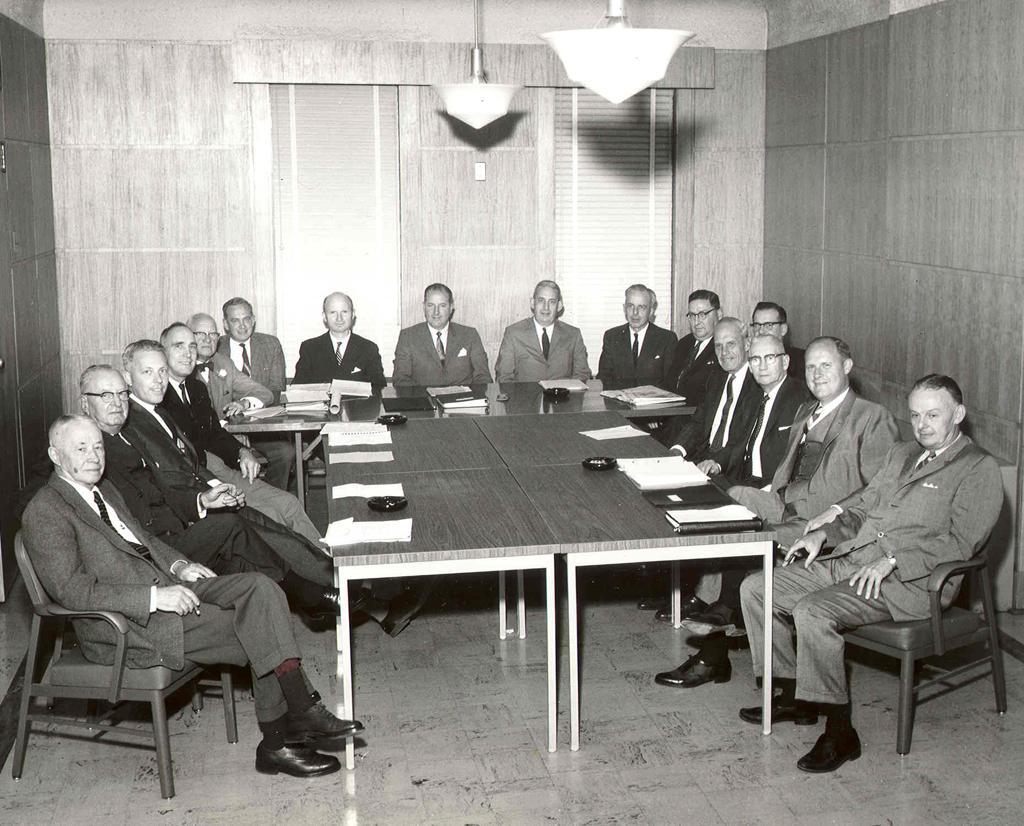Could you give a brief overview of what you see in this image? In the image we can see group of persons were sitting on the chair around the table. On table we can see papers,chart etc. And back there is a wall,door,light. 